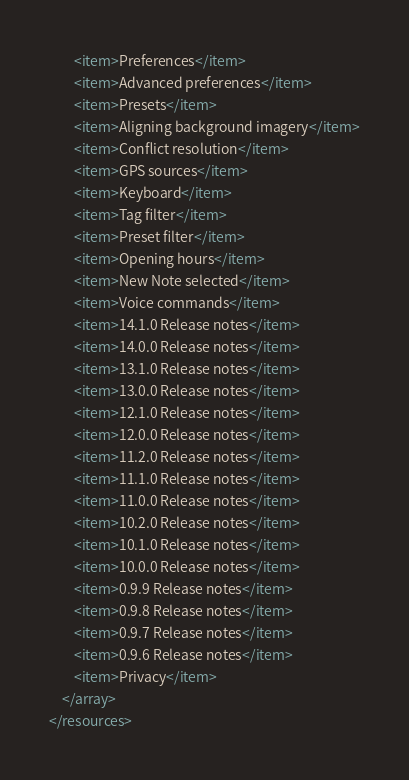<code> <loc_0><loc_0><loc_500><loc_500><_XML_>        <item>Preferences</item>
        <item>Advanced preferences</item>
    	<item>Presets</item>	
    	<item>Aligning background imagery</item>
    	<item>Conflict resolution</item>
    	<item>GPS sources</item>
    	<item>Keyboard</item>
    	<item>Tag filter</item>
    	<item>Preset filter</item>
    	<item>Opening hours</item>
        <item>New Note selected</item>
        <item>Voice commands</item>
        <item>14.1.0 Release notes</item>
        <item>14.0.0 Release notes</item>
        <item>13.1.0 Release notes</item>
        <item>13.0.0 Release notes</item>
        <item>12.1.0 Release notes</item>
        <item>12.0.0 Release notes</item>
        <item>11.2.0 Release notes</item>
        <item>11.1.0 Release notes</item>
        <item>11.0.0 Release notes</item>
        <item>10.2.0 Release notes</item>
    	<item>10.1.0 Release notes</item>
    	<item>10.0.0 Release notes</item>
    	<item>0.9.9 Release notes</item>
    	<item>0.9.8 Release notes</item>
    	<item>0.9.7 Release notes</item>
    	<item>0.9.6 Release notes</item>
        <item>Privacy</item>
    </array>
</resources>
</code> 